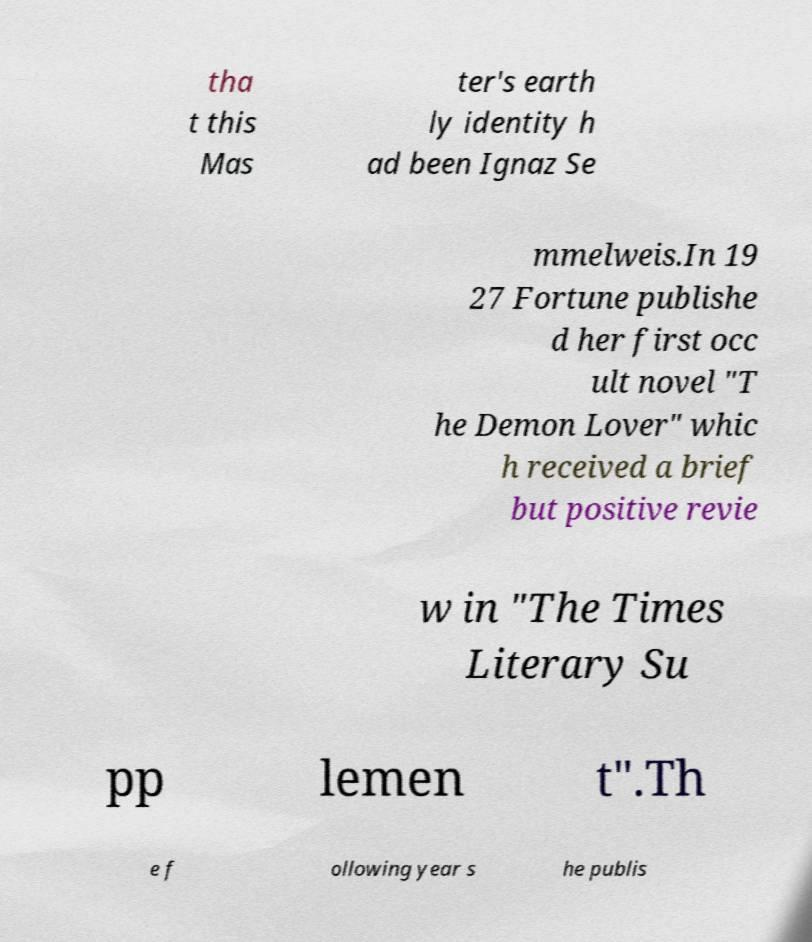Could you extract and type out the text from this image? tha t this Mas ter's earth ly identity h ad been Ignaz Se mmelweis.In 19 27 Fortune publishe d her first occ ult novel "T he Demon Lover" whic h received a brief but positive revie w in "The Times Literary Su pp lemen t".Th e f ollowing year s he publis 